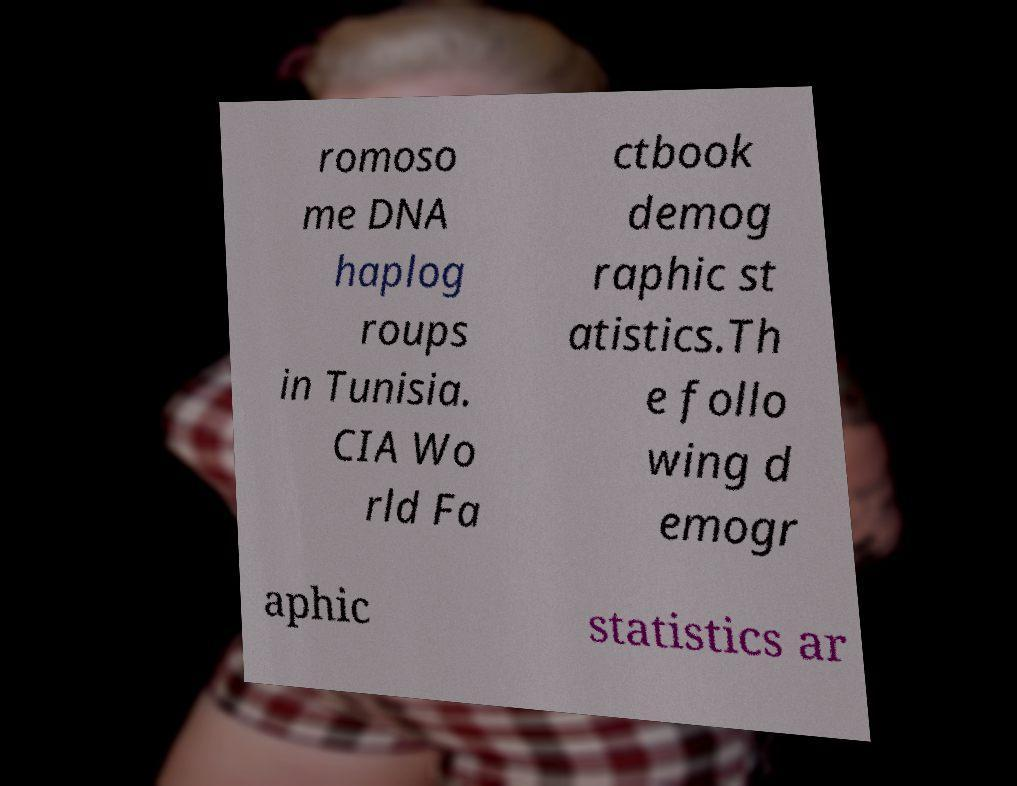Could you assist in decoding the text presented in this image and type it out clearly? romoso me DNA haplog roups in Tunisia. CIA Wo rld Fa ctbook demog raphic st atistics.Th e follo wing d emogr aphic statistics ar 